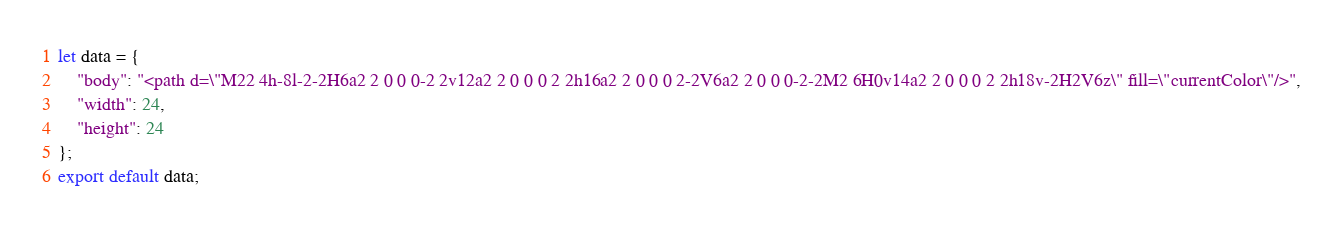<code> <loc_0><loc_0><loc_500><loc_500><_JavaScript_>let data = {
	"body": "<path d=\"M22 4h-8l-2-2H6a2 2 0 0 0-2 2v12a2 2 0 0 0 2 2h16a2 2 0 0 0 2-2V6a2 2 0 0 0-2-2M2 6H0v14a2 2 0 0 0 2 2h18v-2H2V6z\" fill=\"currentColor\"/>",
	"width": 24,
	"height": 24
};
export default data;
</code> 